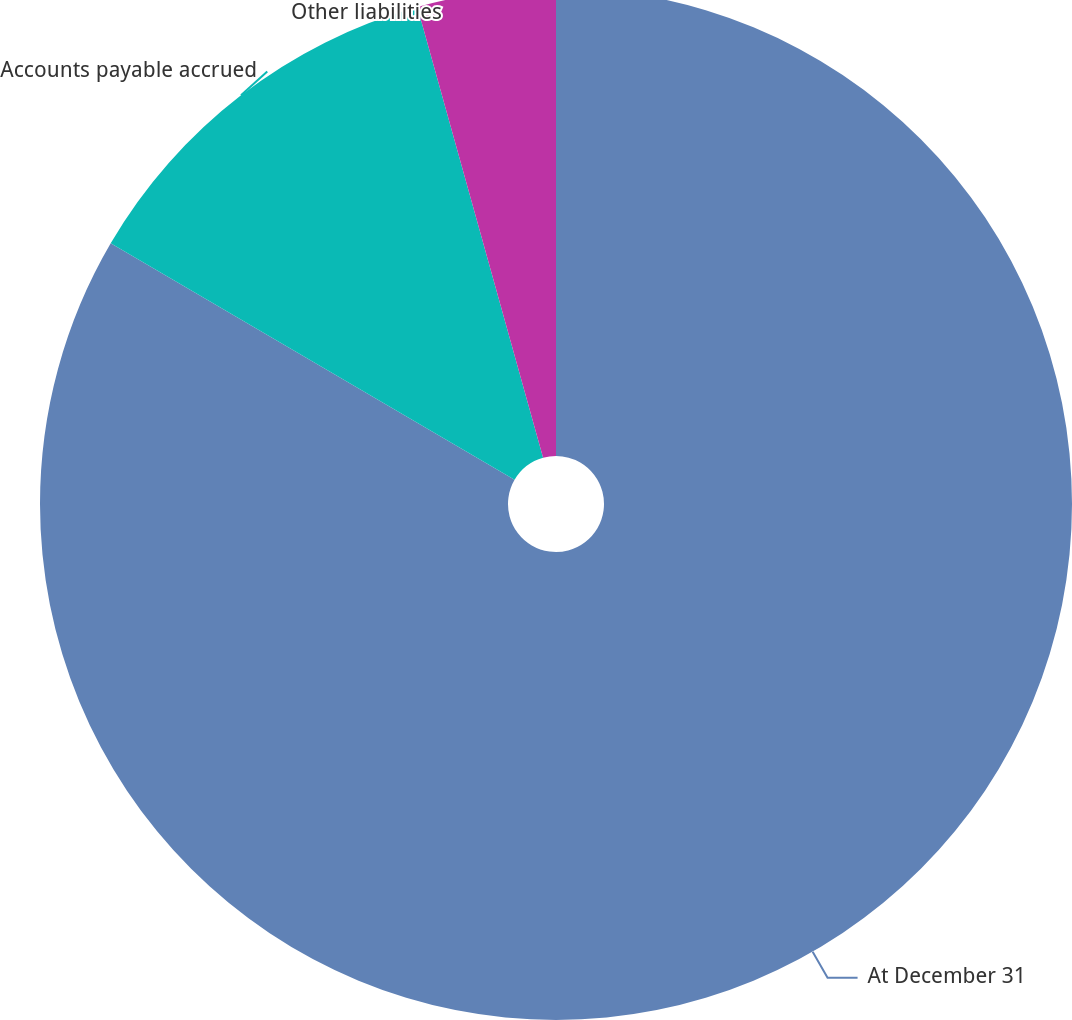<chart> <loc_0><loc_0><loc_500><loc_500><pie_chart><fcel>At December 31<fcel>Accounts payable accrued<fcel>Other liabilities<nl><fcel>83.43%<fcel>12.24%<fcel>4.33%<nl></chart> 